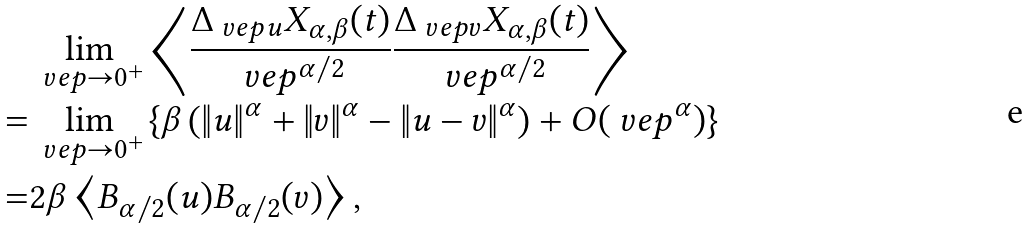Convert formula to latex. <formula><loc_0><loc_0><loc_500><loc_500>& \lim _ { \ v e p \rightarrow 0 ^ { + } } \left \langle \frac { \Delta _ { \ v e p u } X _ { \alpha , \beta } ( t ) } { \ v e p ^ { \alpha / 2 } } \frac { \Delta _ { \ v e p v } X _ { \alpha , \beta } ( t ) } { \ v e p ^ { \alpha / 2 } } \right \rangle \\ = & \lim _ { \ v e p \rightarrow 0 ^ { + } } \left \{ \beta \left ( \| u \| ^ { \alpha } + \| v \| ^ { \alpha } - \| u - v \| ^ { \alpha } \right ) + O ( \ v e p ^ { \alpha } ) \right \} \\ = & 2 \beta \left \langle B _ { \alpha / 2 } ( u ) B _ { \alpha / 2 } ( v ) \right \rangle ,</formula> 